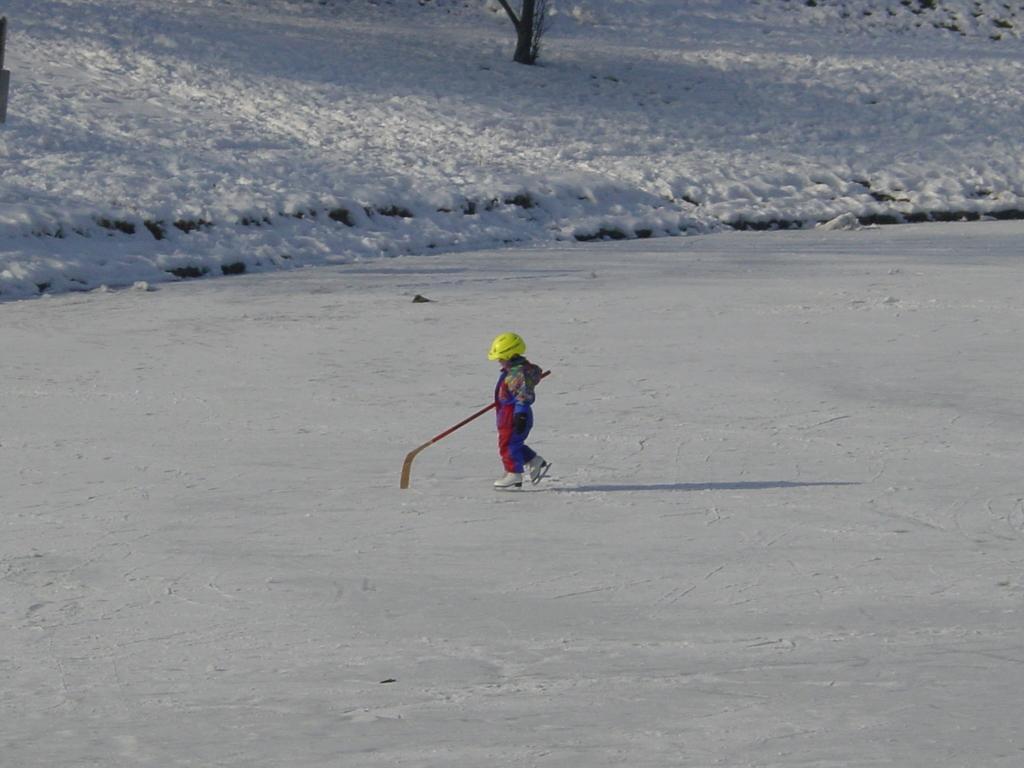Can you describe this image briefly? In this picture we can see a kid on the snow, the kid wore a helmet and holding a stick, in the background we can see a tree. 